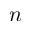<formula> <loc_0><loc_0><loc_500><loc_500>n</formula> 